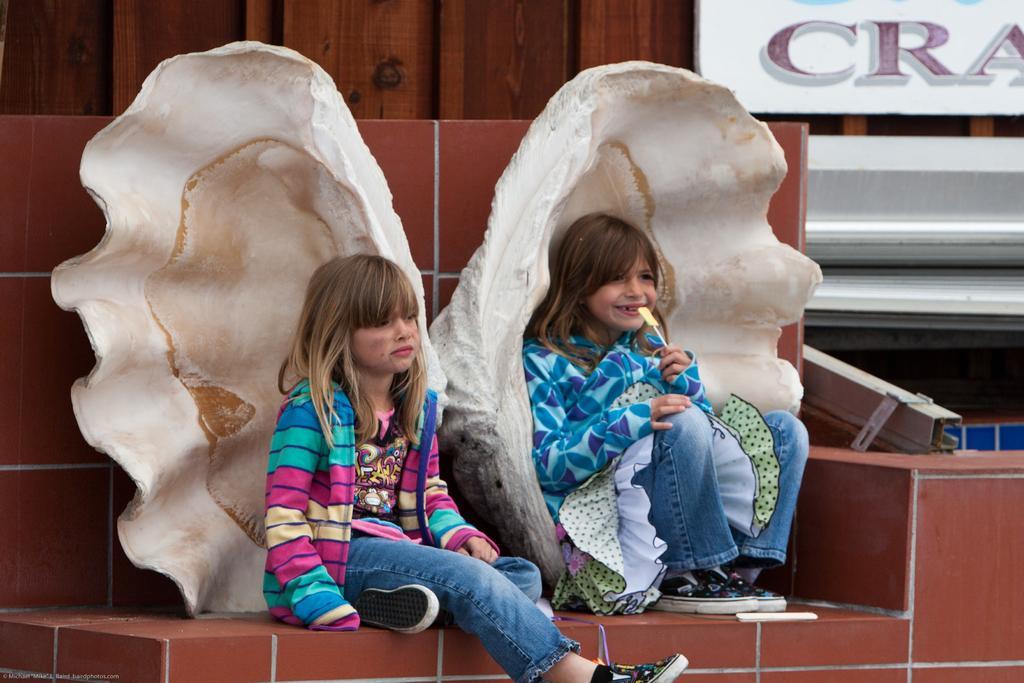Please provide a concise description of this image. In this picture we can see two girls sitting on a brick wall. We can see a girl holding an object in her hand on the right side. There are shells at the back of these girls. We can see a steel object on the right side. There is a text written on a board. We can see a wooden background. 